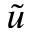<formula> <loc_0><loc_0><loc_500><loc_500>\tilde { u }</formula> 